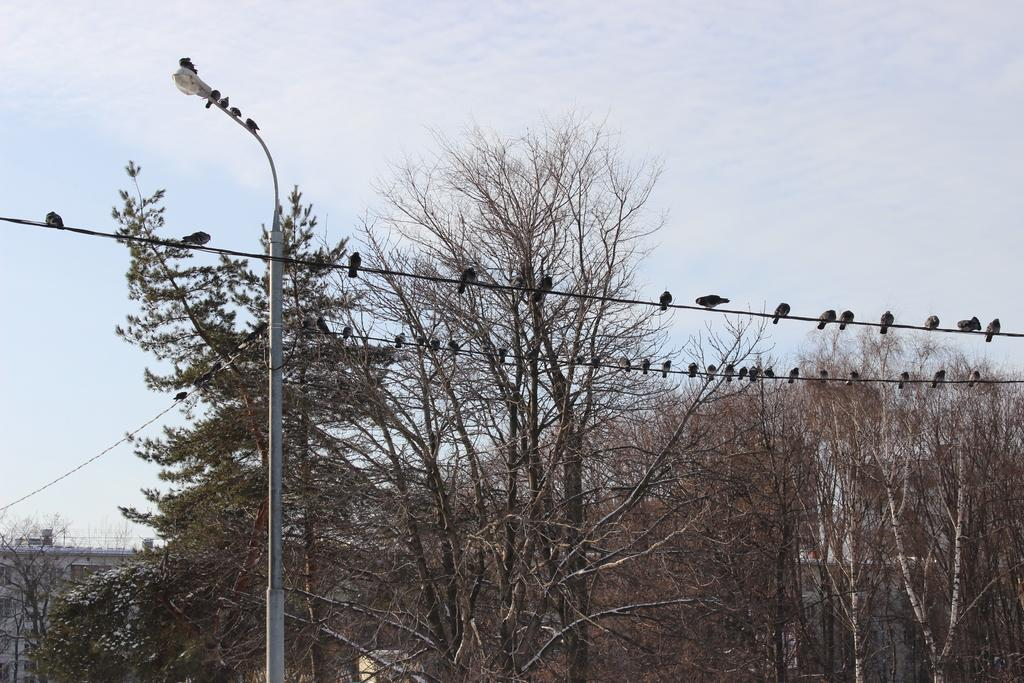What is located on the left side of the image? There is a pole on the left side of the image. What can be seen at the top of the image? There are wires at the top side of the image. What is on the wires in the image? There are birds on the wires. What type of vegetation is present in the image? There are trees in the image. What type of insurance policy do the birds on the wires have? There is no information about insurance policies for the birds in the image. What is the reason for the birds to be on the wires in the image? The image does not provide information about the reason for the birds to be on the wires. 